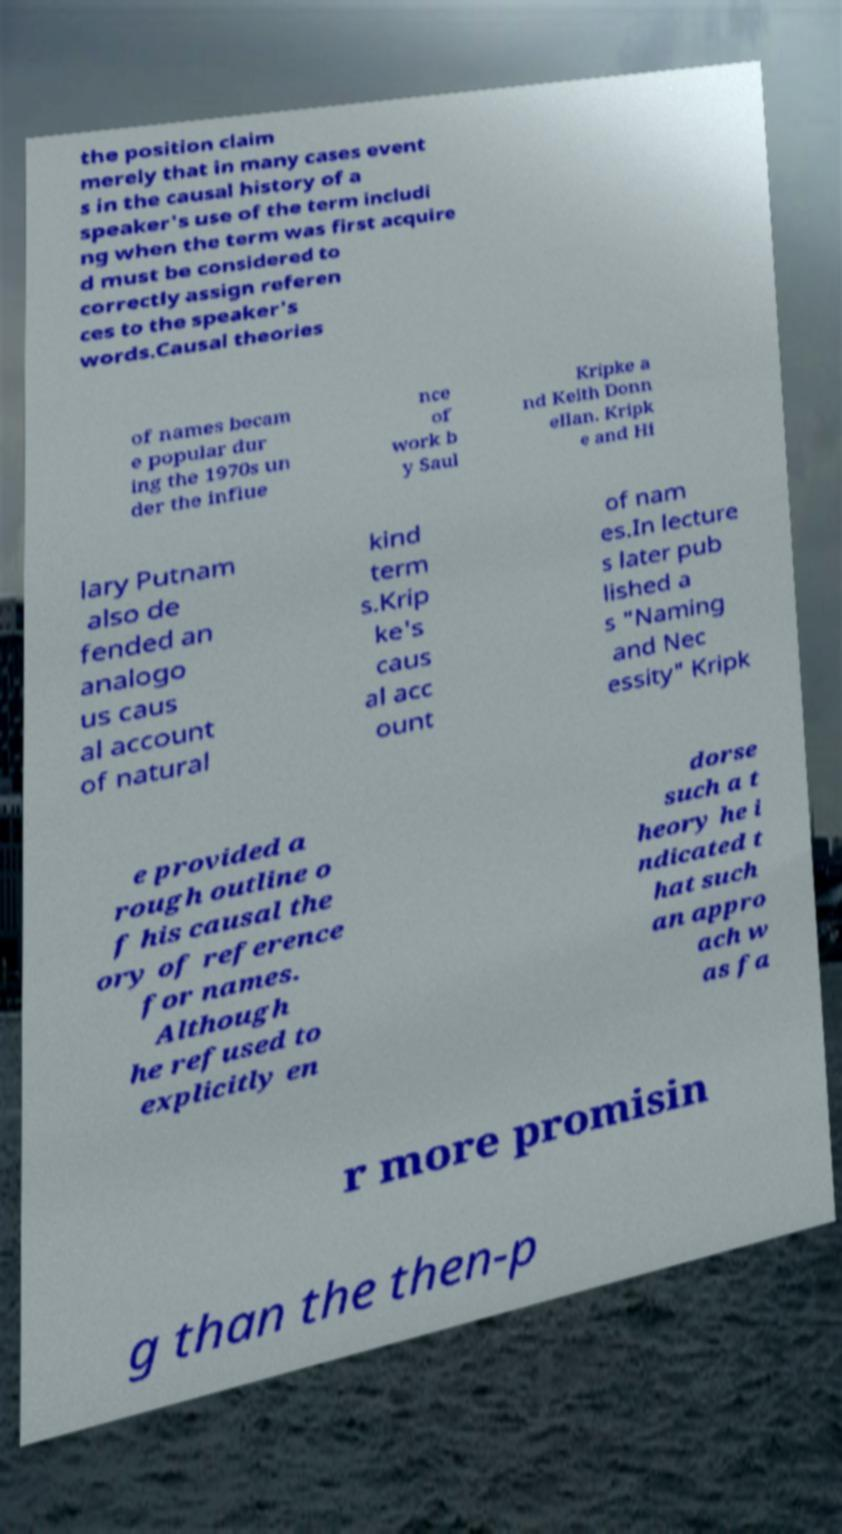Please read and relay the text visible in this image. What does it say? the position claim merely that in many cases event s in the causal history of a speaker's use of the term includi ng when the term was first acquire d must be considered to correctly assign referen ces to the speaker's words.Causal theories of names becam e popular dur ing the 1970s un der the influe nce of work b y Saul Kripke a nd Keith Donn ellan. Kripk e and Hi lary Putnam also de fended an analogo us caus al account of natural kind term s.Krip ke's caus al acc ount of nam es.In lecture s later pub lished a s "Naming and Nec essity" Kripk e provided a rough outline o f his causal the ory of reference for names. Although he refused to explicitly en dorse such a t heory he i ndicated t hat such an appro ach w as fa r more promisin g than the then-p 